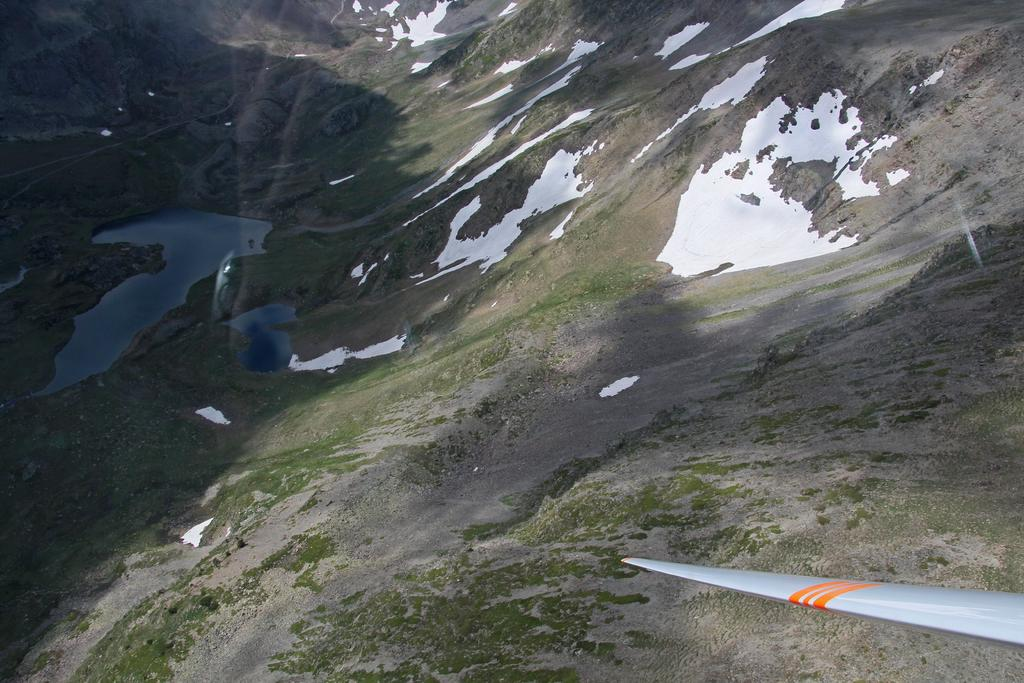What can be found in the right bottom corner of the image? There is an object in the right bottom corner of the image. What type of environment is depicted on the left side of the image? There is water visible on the left side of the image. What is the condition of the ground in the image? Snow is present on the ground at random places in the image. Where is the nest of the knowledgeable bird located in the image? There is no nest or bird present in the image. What type of party is being held in the image? There is no party depicted in the image. 